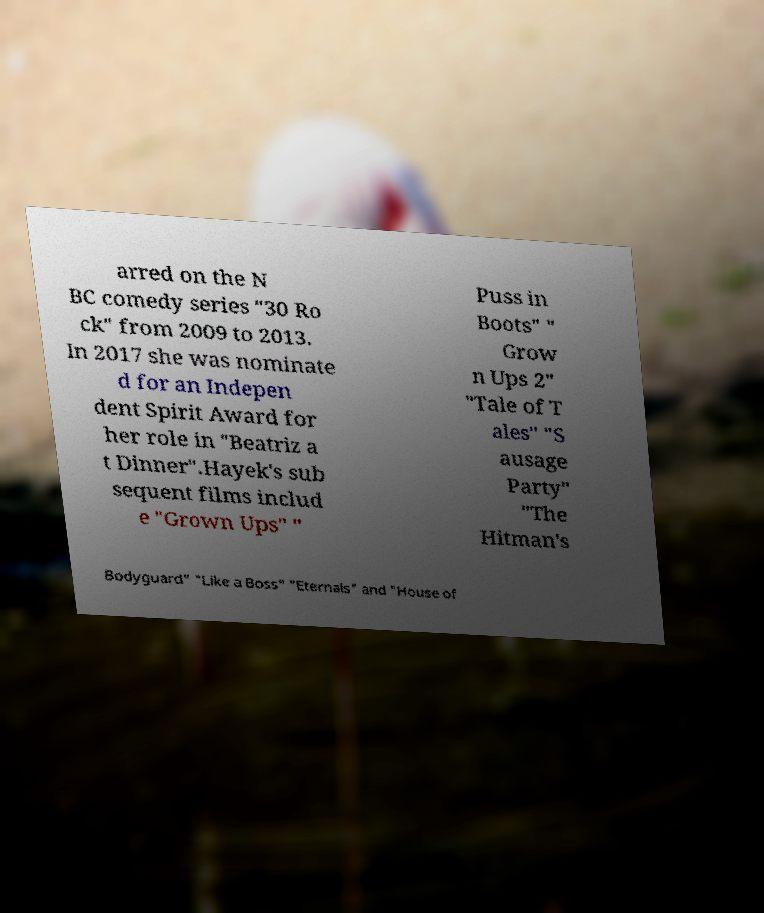Could you assist in decoding the text presented in this image and type it out clearly? arred on the N BC comedy series "30 Ro ck" from 2009 to 2013. In 2017 she was nominate d for an Indepen dent Spirit Award for her role in "Beatriz a t Dinner".Hayek's sub sequent films includ e "Grown Ups" " Puss in Boots" " Grow n Ups 2" "Tale of T ales" "S ausage Party" "The Hitman's Bodyguard" "Like a Boss" "Eternals" and "House of 